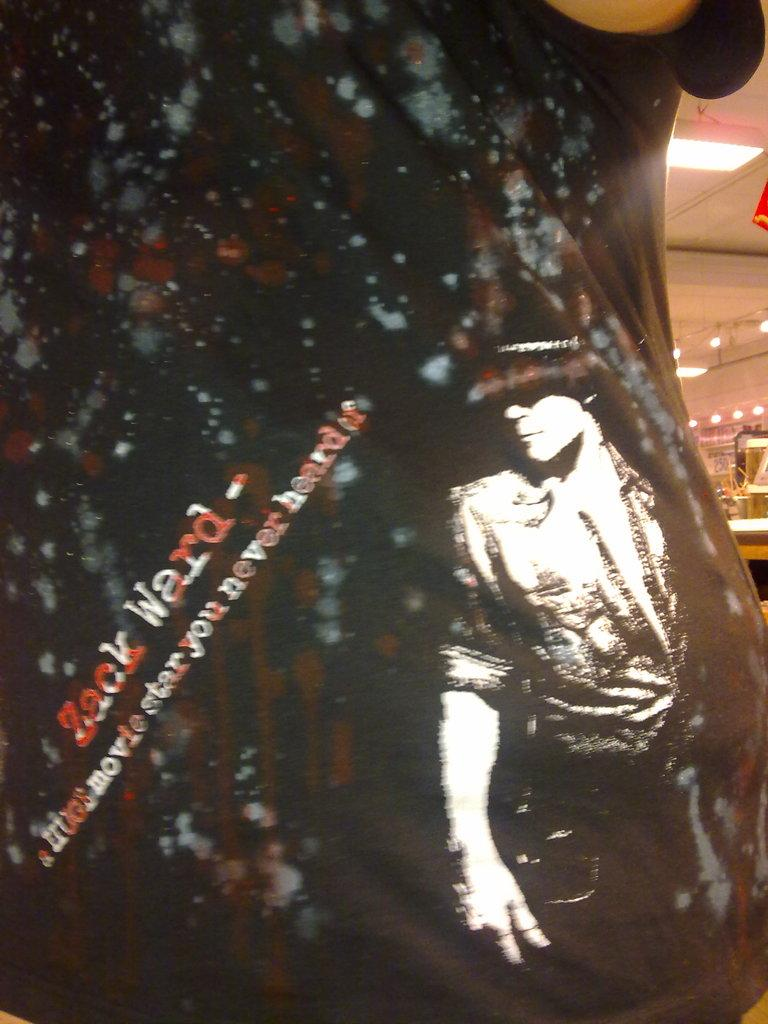Who or what is the main subject in the image? There is a person in the image. What can be seen in the background of the image? There are lights and objects visible in the background of the image. What language is the person speaking in the image? There is no indication of the person speaking in the image, nor is there any information about the language they might be speaking. 